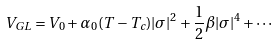<formula> <loc_0><loc_0><loc_500><loc_500>V _ { G L } = V _ { 0 } + \alpha _ { 0 } ( T - T _ { c } ) | \sigma | ^ { 2 } + \frac { 1 } { 2 } \beta | \sigma | ^ { 4 } + \cdots</formula> 